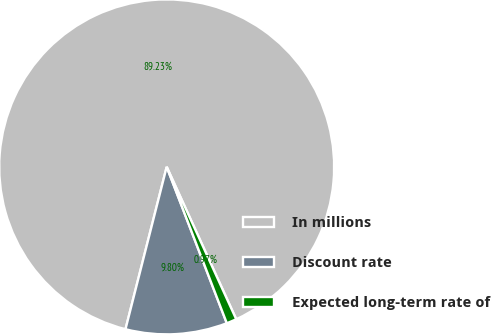Convert chart. <chart><loc_0><loc_0><loc_500><loc_500><pie_chart><fcel>In millions<fcel>Discount rate<fcel>Expected long-term rate of<nl><fcel>89.23%<fcel>9.8%<fcel>0.97%<nl></chart> 